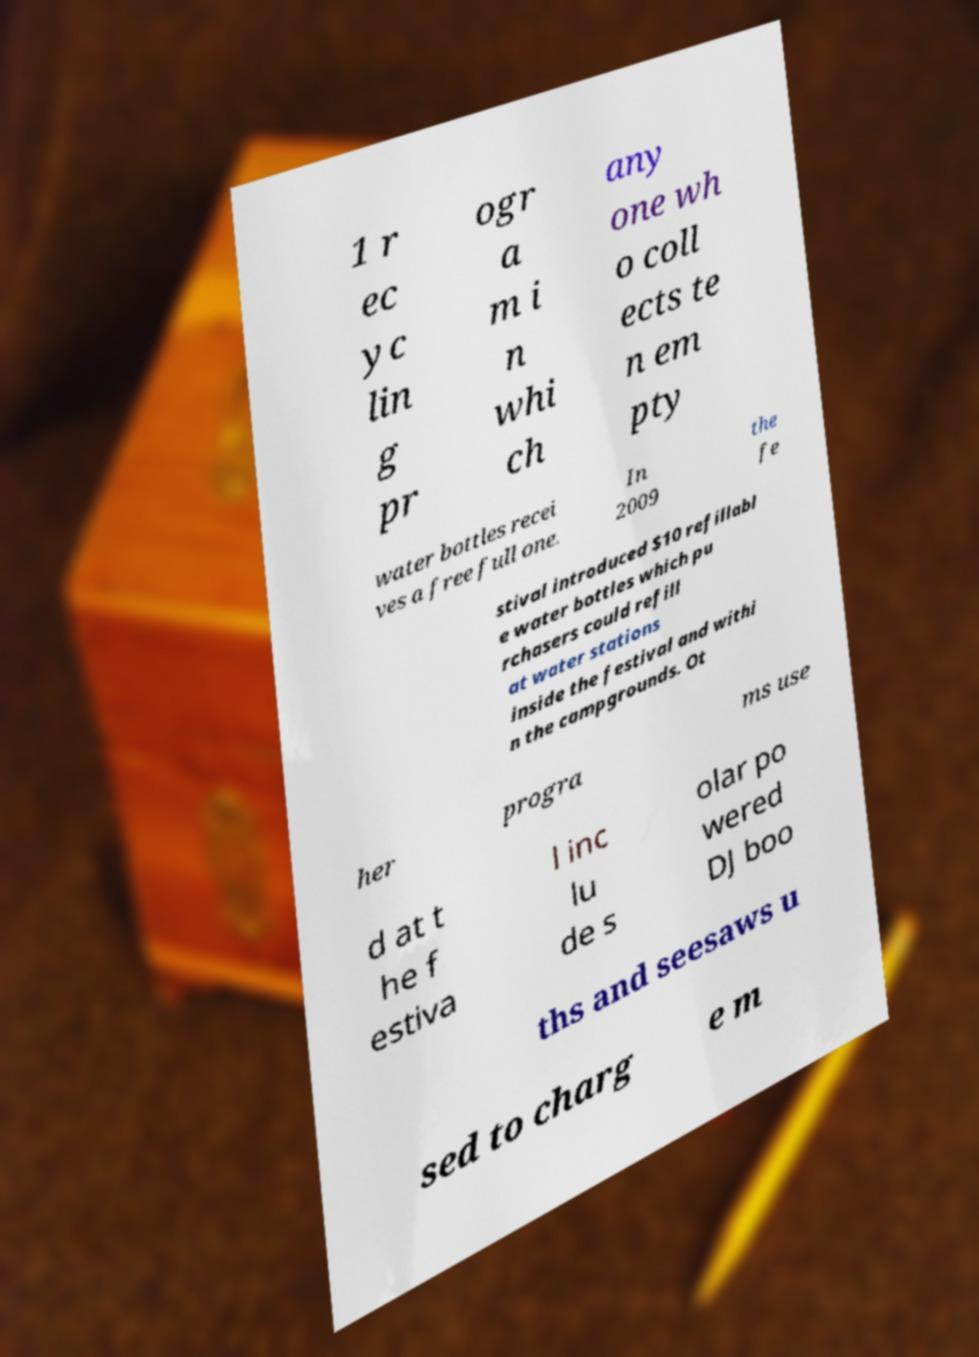I need the written content from this picture converted into text. Can you do that? 1 r ec yc lin g pr ogr a m i n whi ch any one wh o coll ects te n em pty water bottles recei ves a free full one. In 2009 the fe stival introduced $10 refillabl e water bottles which pu rchasers could refill at water stations inside the festival and withi n the campgrounds. Ot her progra ms use d at t he f estiva l inc lu de s olar po wered DJ boo ths and seesaws u sed to charg e m 